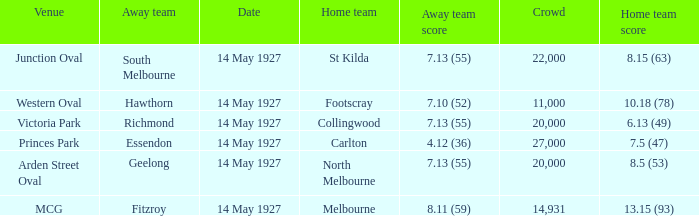How much is the sum of every crowd in attendance when the away score was 7.13 (55) for Richmond? 20000.0. 